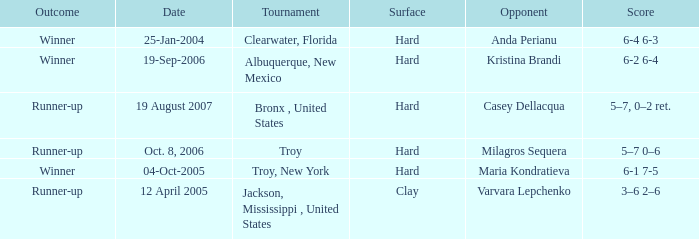What was the surface of the game that resulted in a final score of 6-1 7-5? Hard. 